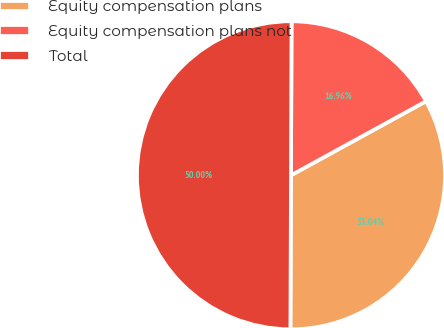Convert chart to OTSL. <chart><loc_0><loc_0><loc_500><loc_500><pie_chart><fcel>Equity compensation plans<fcel>Equity compensation plans not<fcel>Total<nl><fcel>33.04%<fcel>16.96%<fcel>50.0%<nl></chart> 